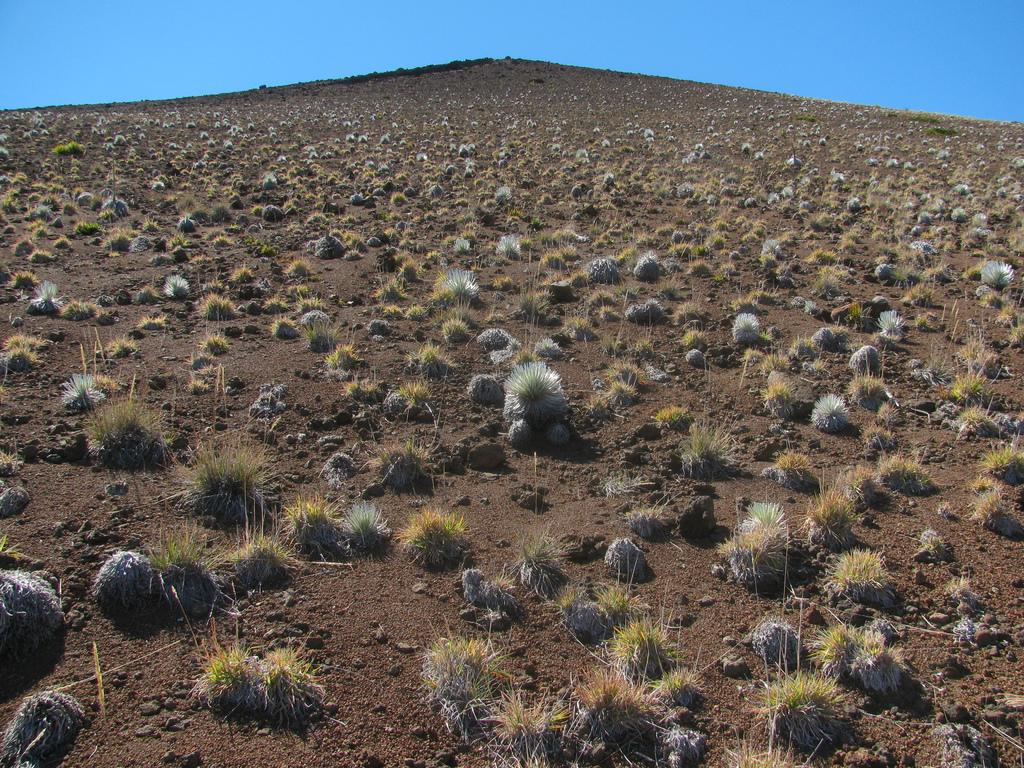What type of living organisms can be seen in the image? Plants can be seen in the image. What part of the natural environment is visible in the image? The sky is visible in the background of the image. What color is the floor in the image? There is no floor present in the image, as it features plants and sky. 